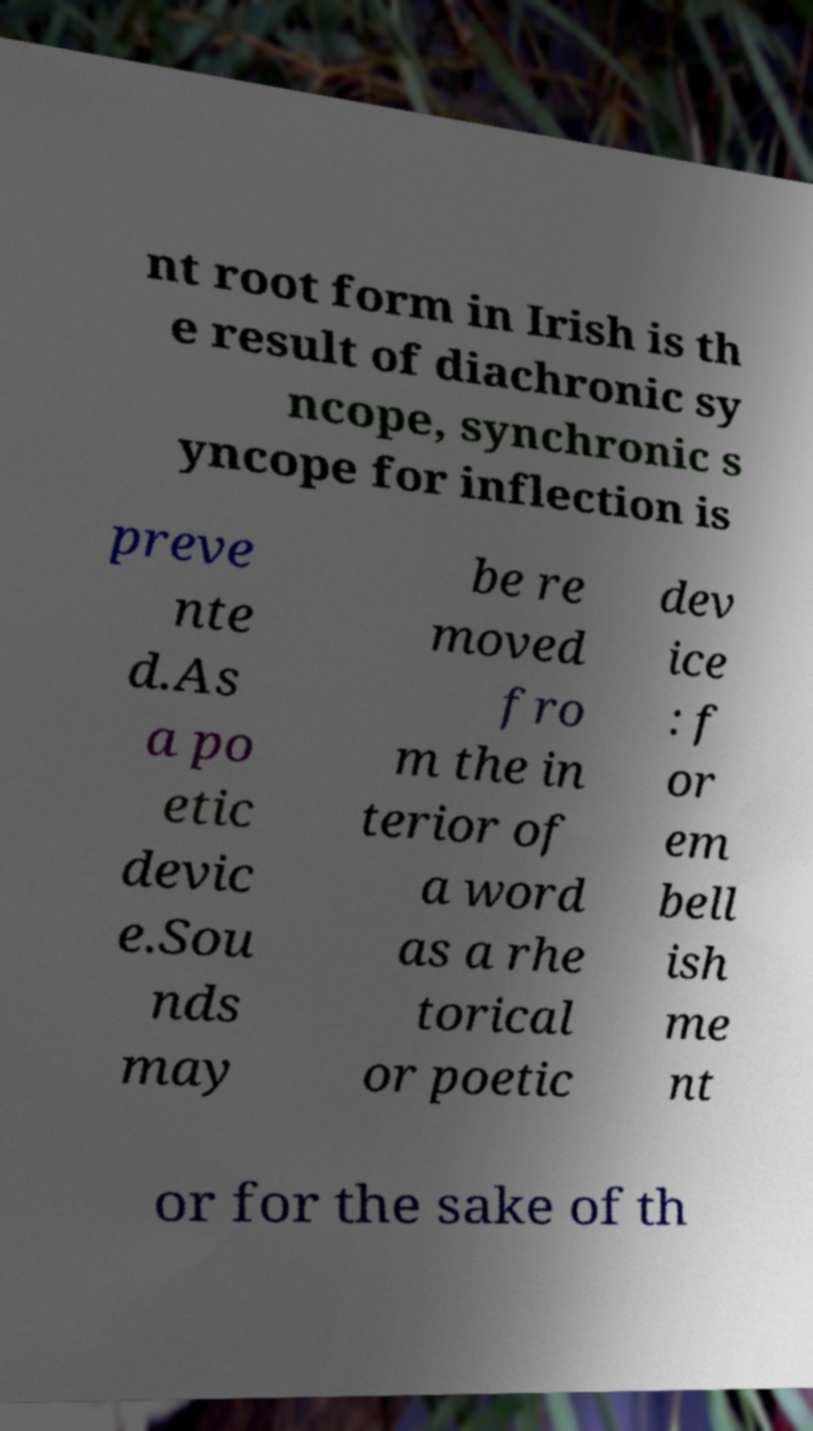Could you extract and type out the text from this image? nt root form in Irish is th e result of diachronic sy ncope, synchronic s yncope for inflection is preve nte d.As a po etic devic e.Sou nds may be re moved fro m the in terior of a word as a rhe torical or poetic dev ice : f or em bell ish me nt or for the sake of th 